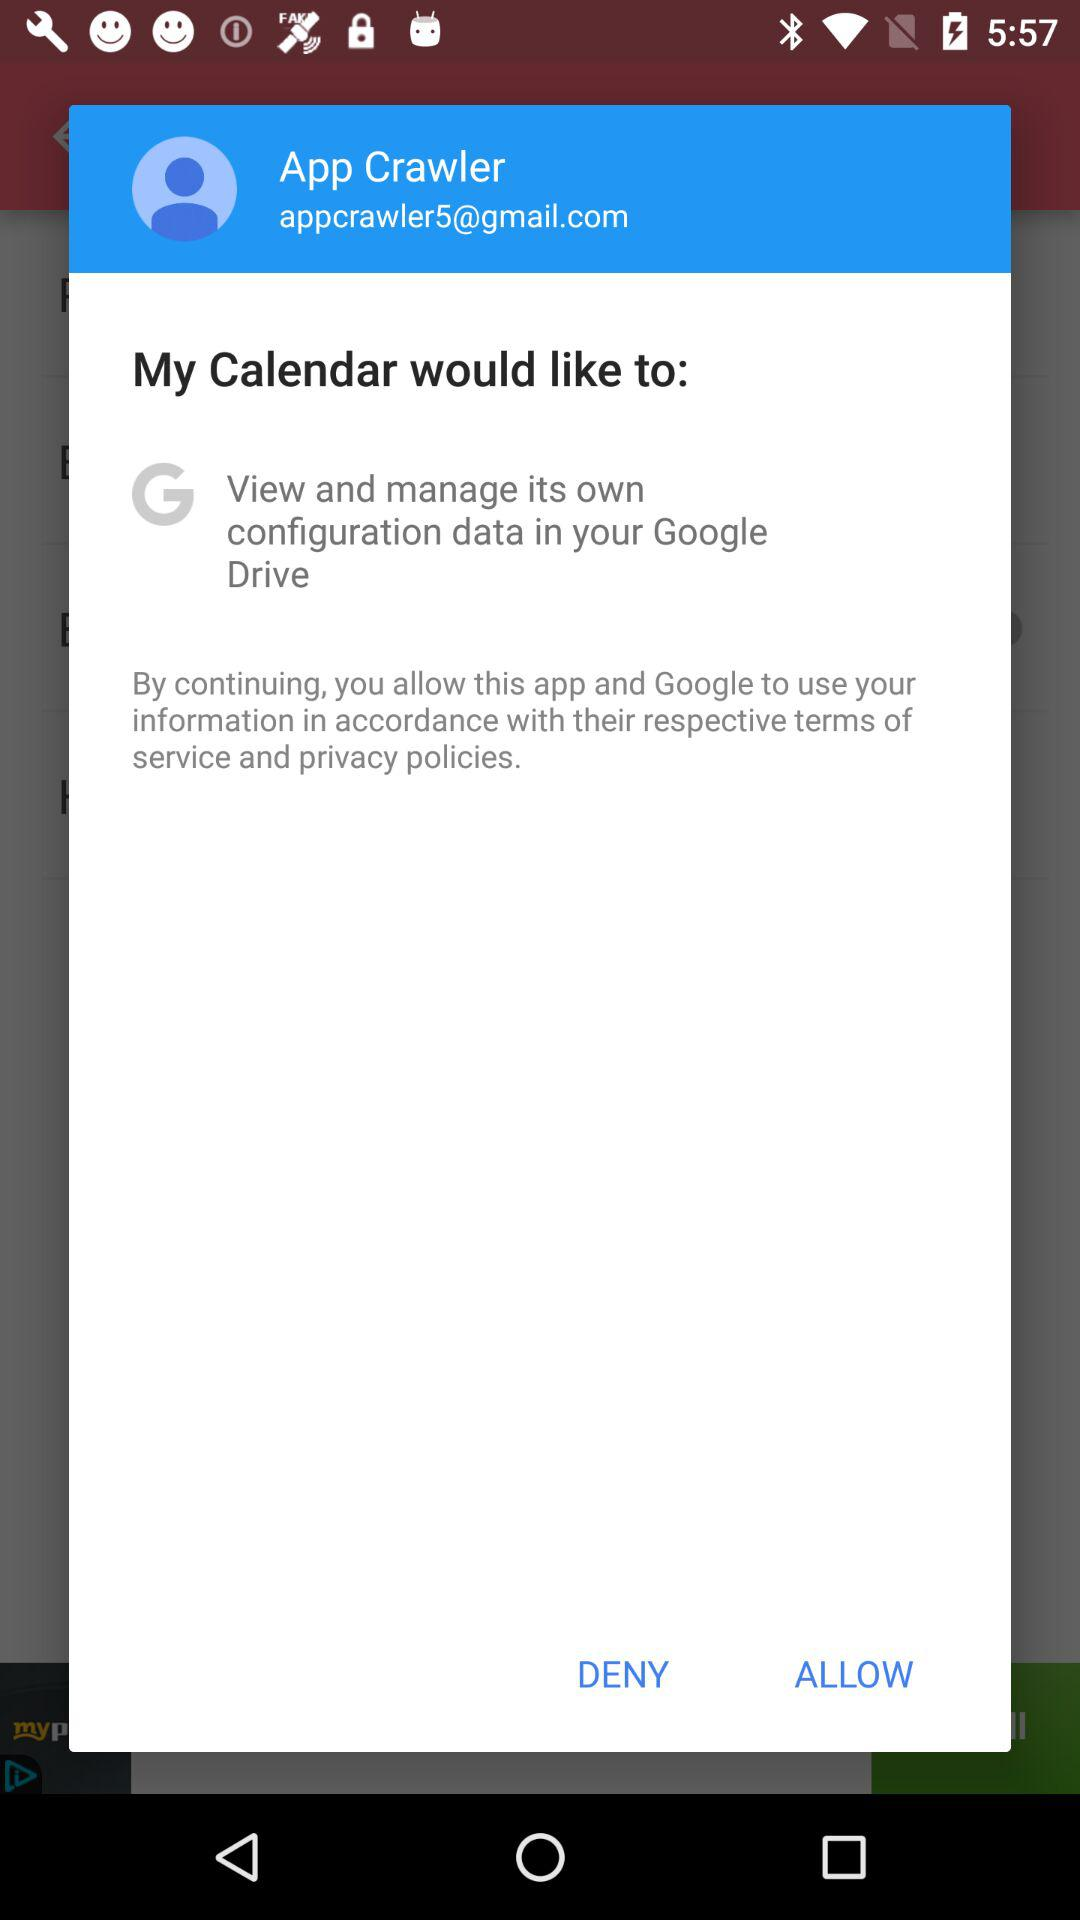What's the email address used by user for application? The email address is "appcrawler5@gmail.com". 